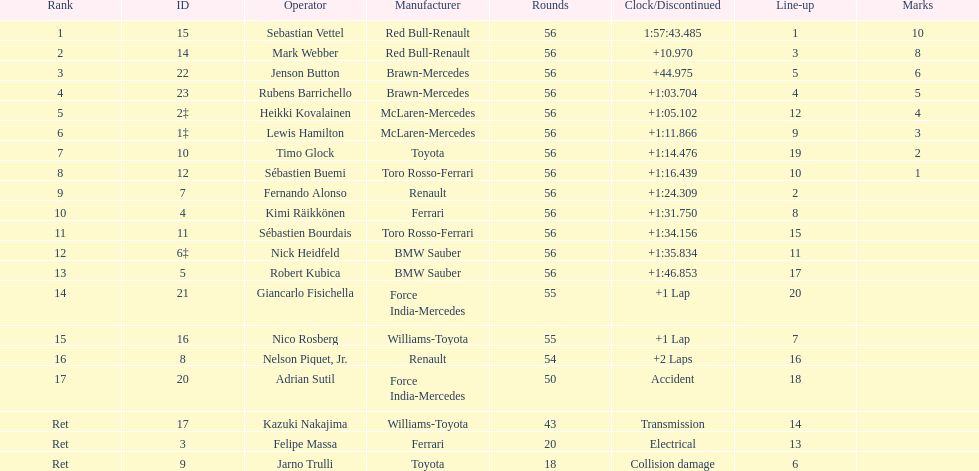Which driver was final on the list? Jarno Trulli. 